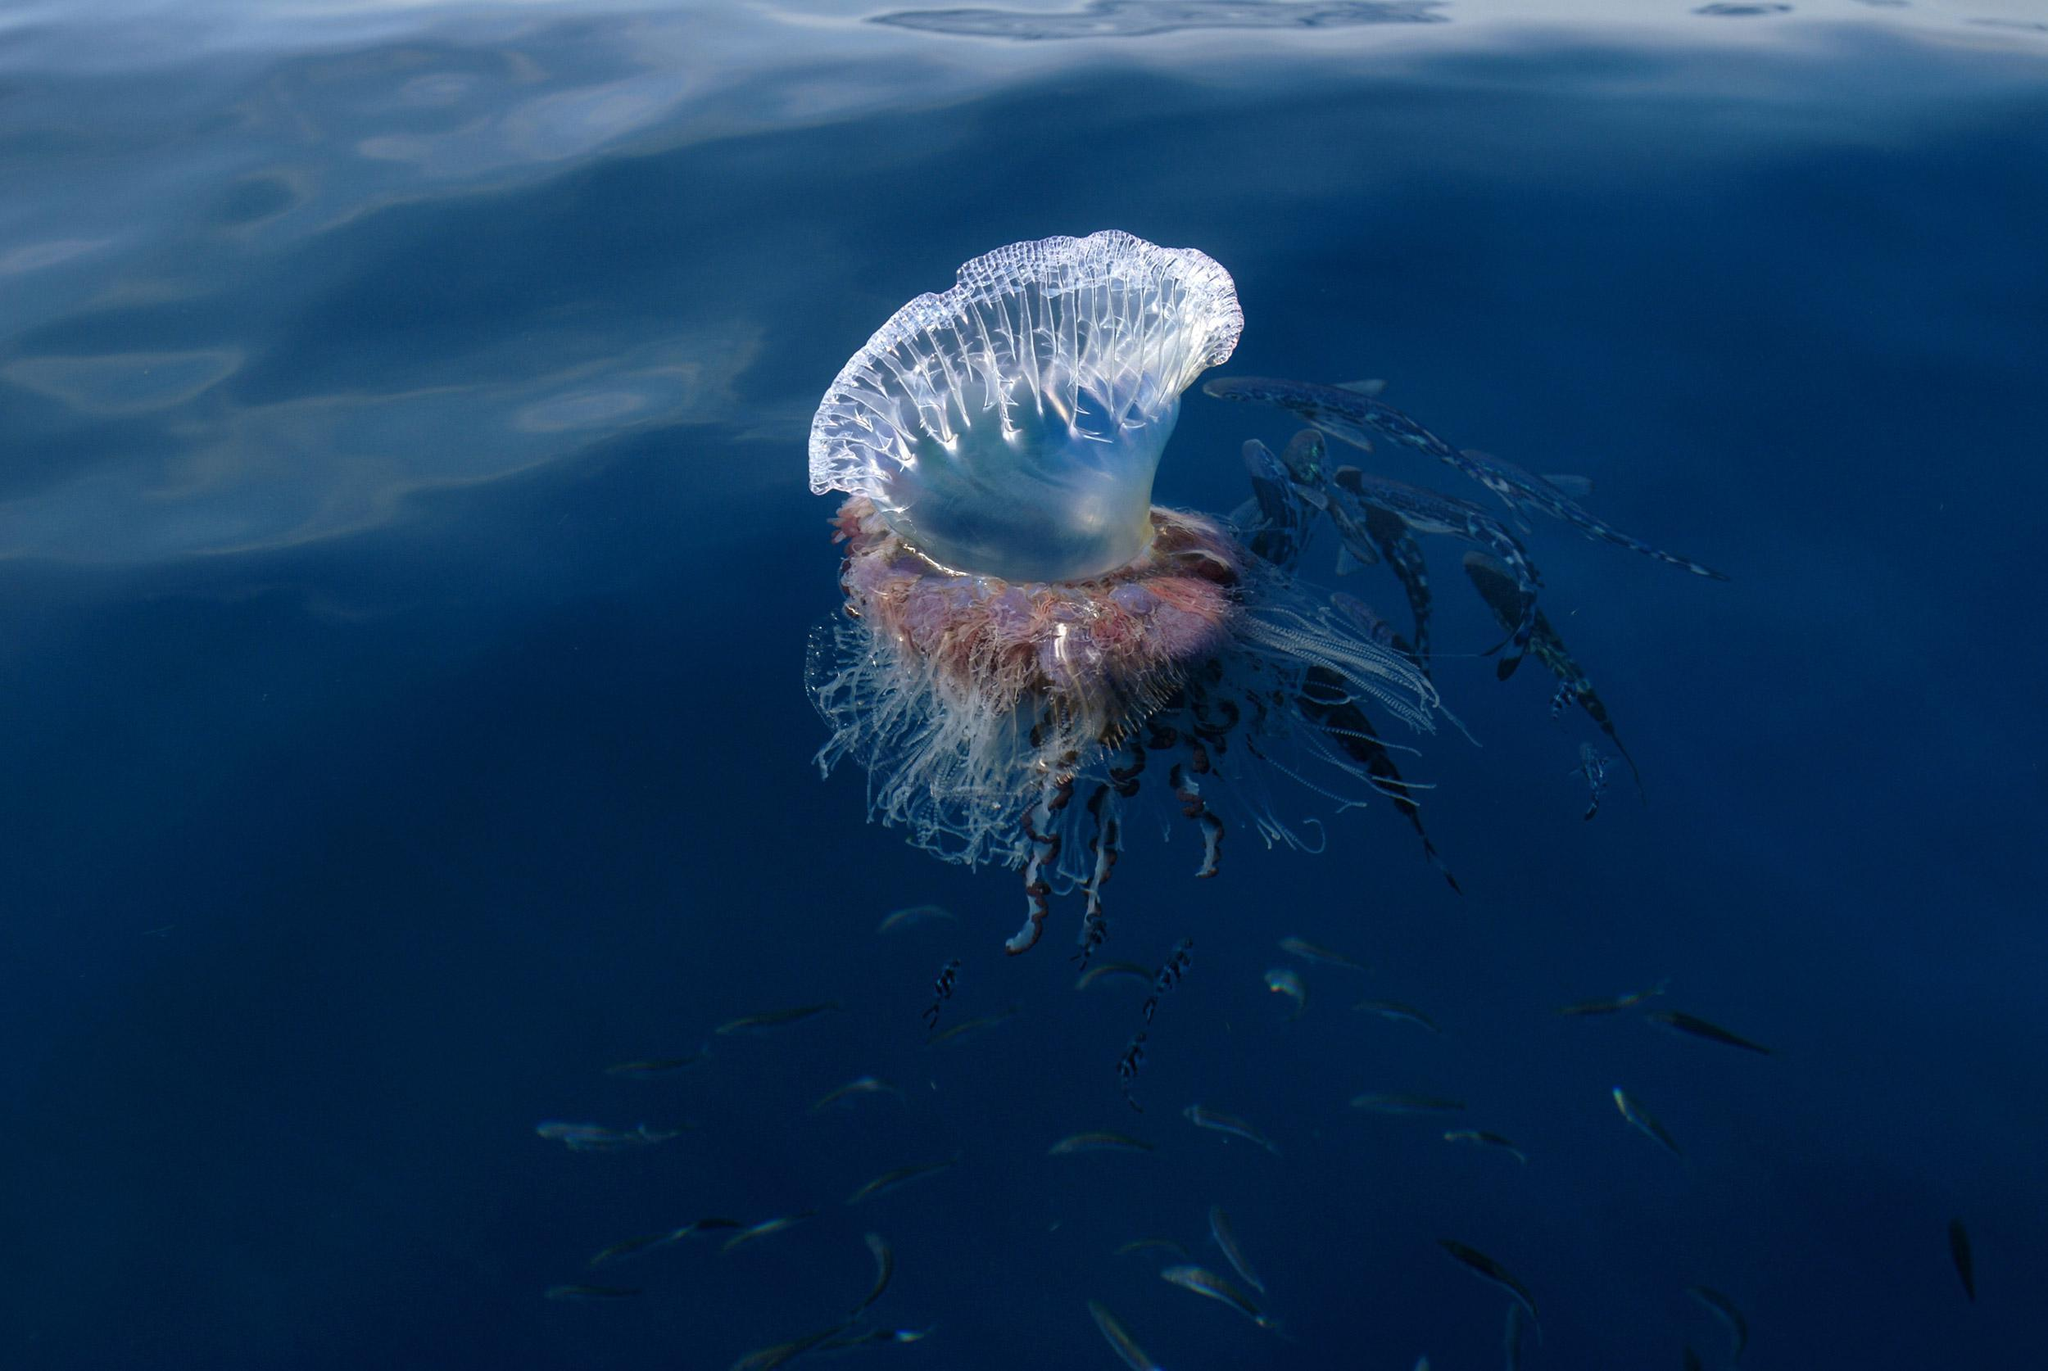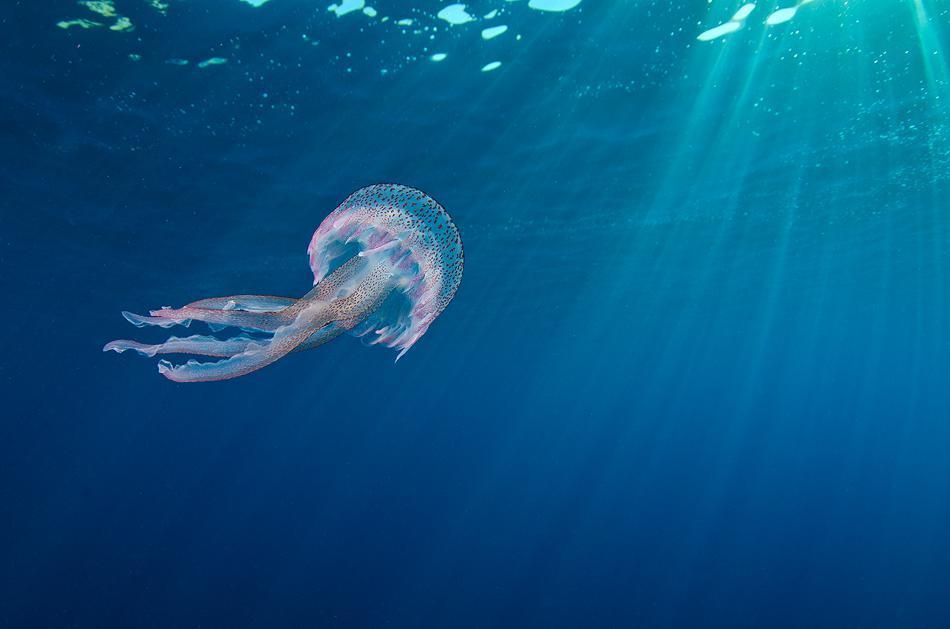The first image is the image on the left, the second image is the image on the right. Assess this claim about the two images: "All jellyfish are at least partially above the water surface.". Correct or not? Answer yes or no. No. 